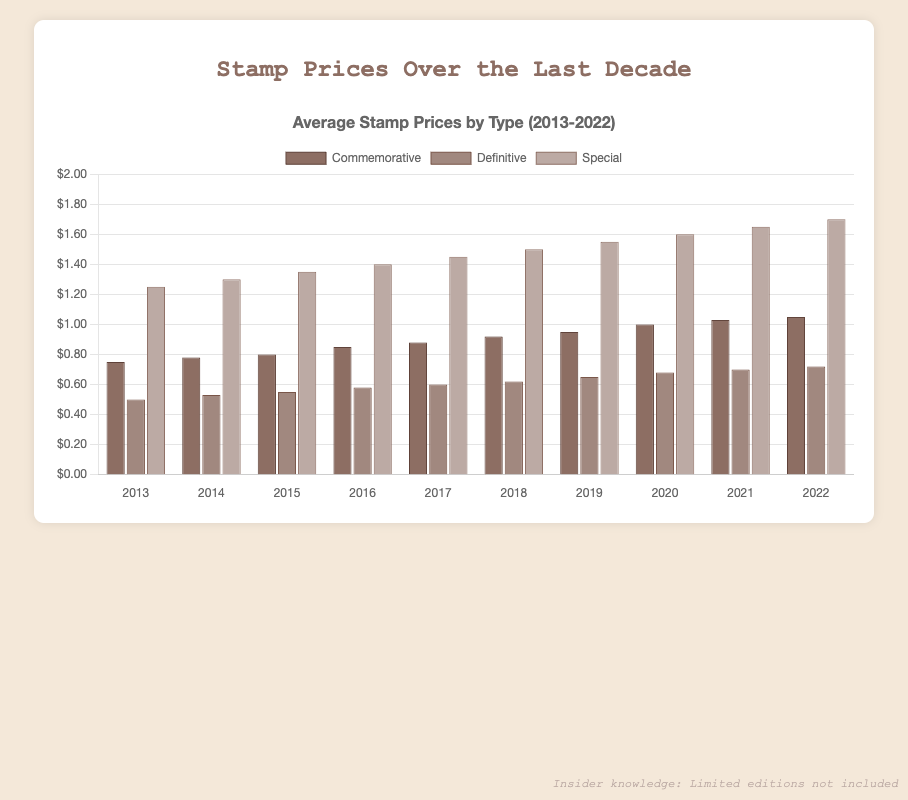What was the average price of a Special stamp in 2020? Look at the bar corresponding to the Special stamps category in 2020. The height of the bar indicates the price.
Answer: 1.60 Which type of stamp had the highest average price in 2015? Compare the heights of the bars for Commemorative, Definitive, and Special stamps in 2015. The tallest bar corresponds to the highest price.
Answer: Special How much did the price of Commemorative stamps increase from 2013 to 2022? Subtract the price of Commemorative stamps in 2013 from the price in 2022. 1.05 (2022) - 0.75 (2013) = 0.30
Answer: 0.30 Between which years did the price of Definitive stamps see the greatest increase? Calculate the year-to-year differences in the average prices for Definitive stamps and find the years with the largest difference. From 2020 to 2021, the increase is 0.70 - 0.68 = 0.02, which is the largest increment in the range.
Answer: 2020-2021 Which type of stamp consistently had the lowest average price each year? Compare the bars of Commemorative, Definitive, and Special stamps across all years. The type with the shortest bars consistently has the lowest price.
Answer: Definitive How much more expensive were Special stamps compared to Definitive stamps in 2022? Subtract the price of Definitive stamps in 2022 from the price of Special stamps in 2022. 1.70 - 0.72 = 0.98
Answer: 0.98 What is the average price of Commemorative, Definitive, and Special stamps in 2022 combined? Sum the prices in 2022 and divide by the number of types. (1.05 + 0.72 + 1.70) / 3 = 3.47 / 3 = 1.1567
Answer: 1.16 By how much did the price of Special stamps increase from 2013 to 2022? Subtract the average price of Special stamps in 2013 from the average price in 2022. 1.70 (2022) - 1.25 (2013) = 0.45
Answer: 0.45 Which type of stamp had the least price increase from 2013 to 2022? Calculate the increase for each type of stamp from 2013 to 2022. The smallest increase will indicate the type with the least price growth. Commemorative increased by 0.30, Definitive by 0.22, and Special by 0.45. The least is Definitive.
Answer: Definitive 